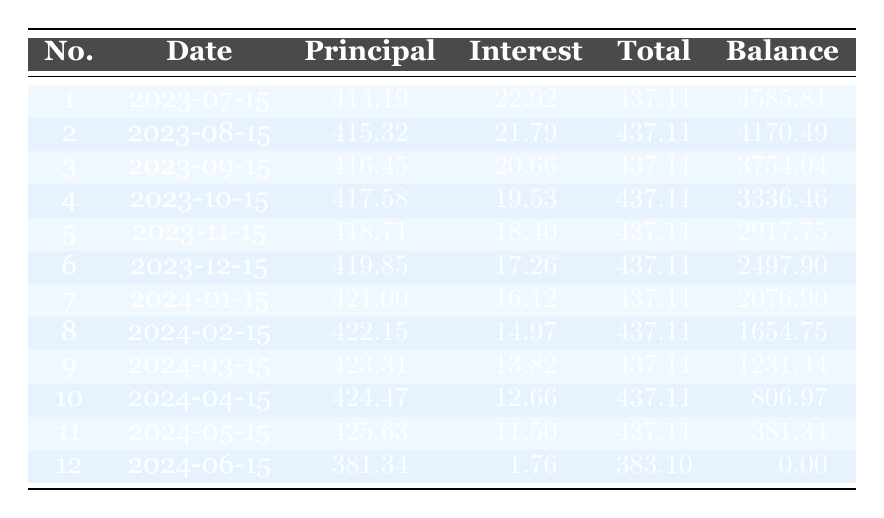What is the total loan amount? The total loan amount provided in the loan details is stated clearly as $5000.
Answer: 5000 What is the interest payment for the first month? The table shows that the interest payment for the first month (July 15, 2023) is $22.92.
Answer: 22.92 What is the remaining balance after the 6th payment? To find the remaining balance after the 6th payment, we can refer directly to the table, which states it as $2497.90.
Answer: 2497.90 What is the average monthly principal payment for the first three payments? The principal payments for the first three months are $414.19, $415.32, and $416.45. We sum these values: (414.19 + 415.32 + 416.45) = 1246.96. Then divide by 3 to find the average: 1246.96 / 3 = 415.65.
Answer: 415.65 Is the total payment for the last month less than the total payment for the first month? The total payment for the last month (June 15, 2024) is $383.10, while for the first month (July 15, 2023) it is $437.11. Since $383.10 is less than $437.11, the answer is yes.
Answer: Yes What is the principal payment for the 12th month? Looking at the table, the principal payment for the 12th month (June 15, 2024) is stated as $381.34.
Answer: 381.34 How much total interest was paid over the entire loan period? To find the total interest paid, we can add all the interest payments from each of the 12 payments. Summing them gives us: (22.92 + 21.79 + 20.66 + 19.53 + 18.40 + 17.26 + 16.12 + 14.97 + 13.82 + 12.66 + 11.50 + 1.76) =  260.14.
Answer: 260.14 What is the difference between the total payment for the 5th and 10th months? The total payment for the 5th month is $437.11 and for the 10th month is $437.11 as well. To find the difference, we calculate: $437.11 - $437.11 = $0.
Answer: 0 Is the interest payment decreasing each month? Checking the table, each month's interest payment shows a decreasing trend: 22.92, 21.79, 20.66, etc., confirming that the interest payment does decrease monthly.
Answer: Yes 